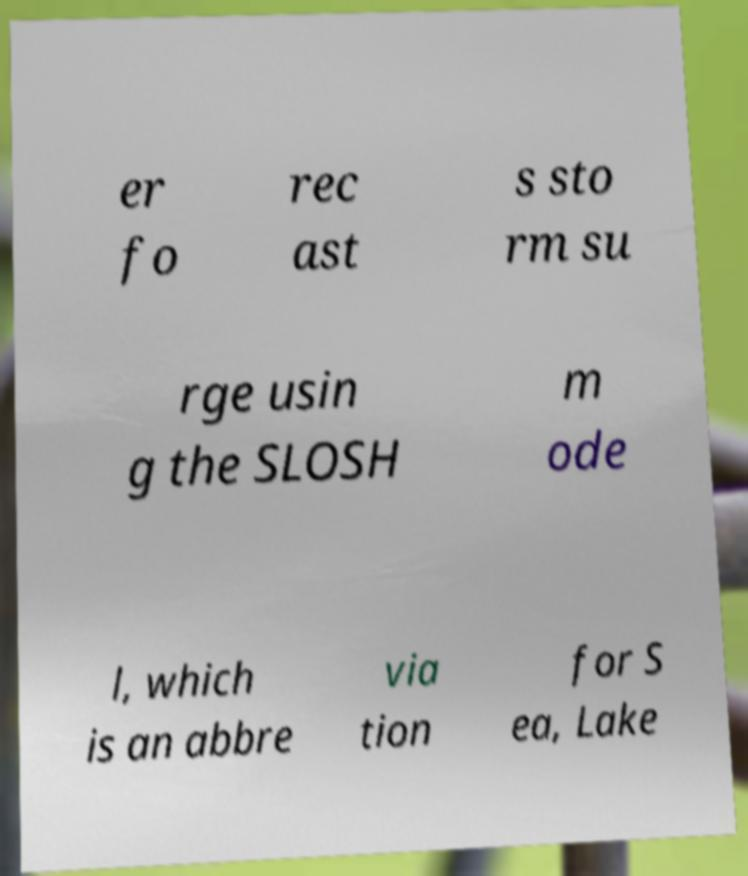Can you read and provide the text displayed in the image?This photo seems to have some interesting text. Can you extract and type it out for me? er fo rec ast s sto rm su rge usin g the SLOSH m ode l, which is an abbre via tion for S ea, Lake 